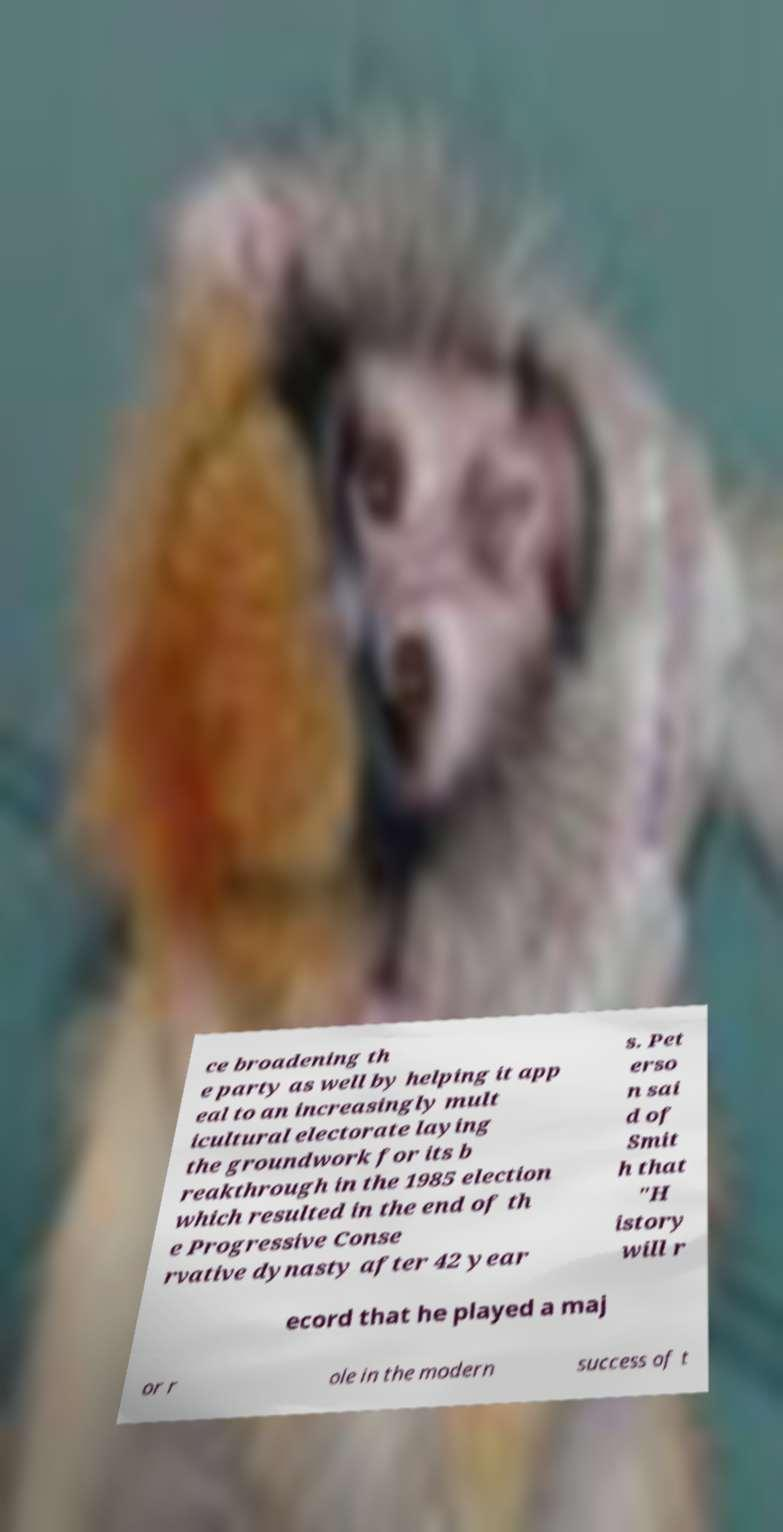What messages or text are displayed in this image? I need them in a readable, typed format. ce broadening th e party as well by helping it app eal to an increasingly mult icultural electorate laying the groundwork for its b reakthrough in the 1985 election which resulted in the end of th e Progressive Conse rvative dynasty after 42 year s. Pet erso n sai d of Smit h that "H istory will r ecord that he played a maj or r ole in the modern success of t 